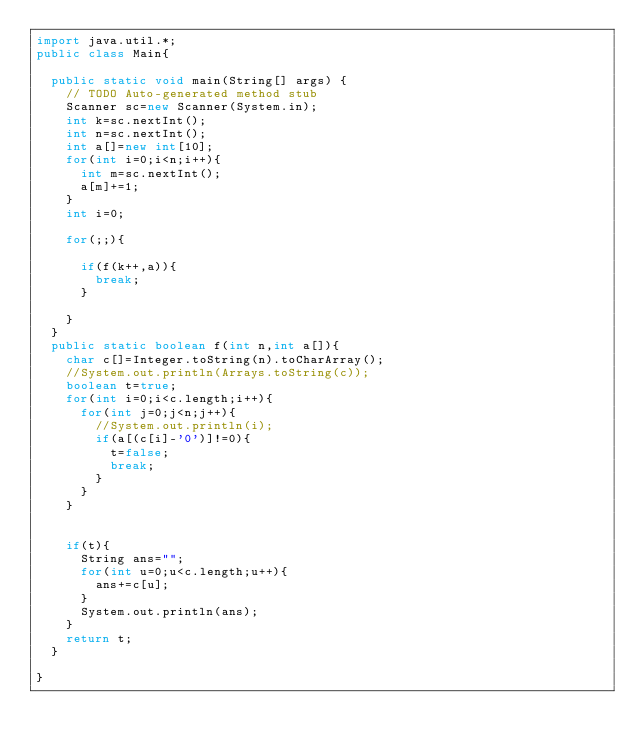<code> <loc_0><loc_0><loc_500><loc_500><_Java_>import java.util.*;
public class Main{

	public static void main(String[] args) {
		// TODO Auto-generated method stub
		Scanner sc=new Scanner(System.in);
		int k=sc.nextInt();
		int n=sc.nextInt();
		int a[]=new int[10];
		for(int i=0;i<n;i++){
			int m=sc.nextInt();
			a[m]+=1;
		}
		int i=0;
	
		for(;;){
			
			if(f(k++,a)){
				break;
			}
			
		}
	}
	public static boolean f(int n,int a[]){
		char c[]=Integer.toString(n).toCharArray();
		//System.out.println(Arrays.toString(c));
		boolean t=true;
		for(int i=0;i<c.length;i++){
			for(int j=0;j<n;j++){
				//System.out.println(i);
				if(a[(c[i]-'0')]!=0){
					t=false;
					break;
				}
			}
		}
		
		
		if(t){
			String ans="";
			for(int u=0;u<c.length;u++){
				ans+=c[u];
			}
			System.out.println(ans);
		}
		return t;
	}

}</code> 